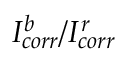Convert formula to latex. <formula><loc_0><loc_0><loc_500><loc_500>I _ { c o r r } ^ { b } / I _ { c o r r } ^ { r }</formula> 